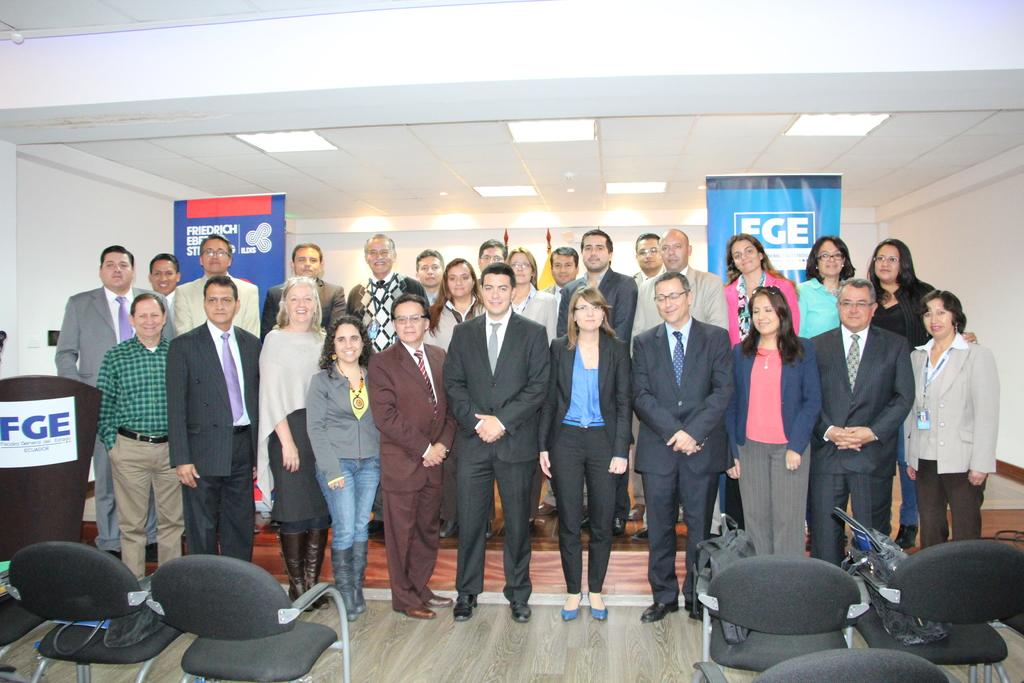How many people are in the image? There is a group of people in the image. What are the people in the image doing? The people are standing and smiling. What is in front of the group of people? There are chairs in front of the group. What can be seen at the top of the image? There are lights visible at the top of the image. What type of signage is present in the image? There are hoardings in the image. What is the background of the image made of? There is a wall in the image. What suggestion does the grandmother make in the image? There is no grandmother present in the image, and therefore no suggestion can be made. 